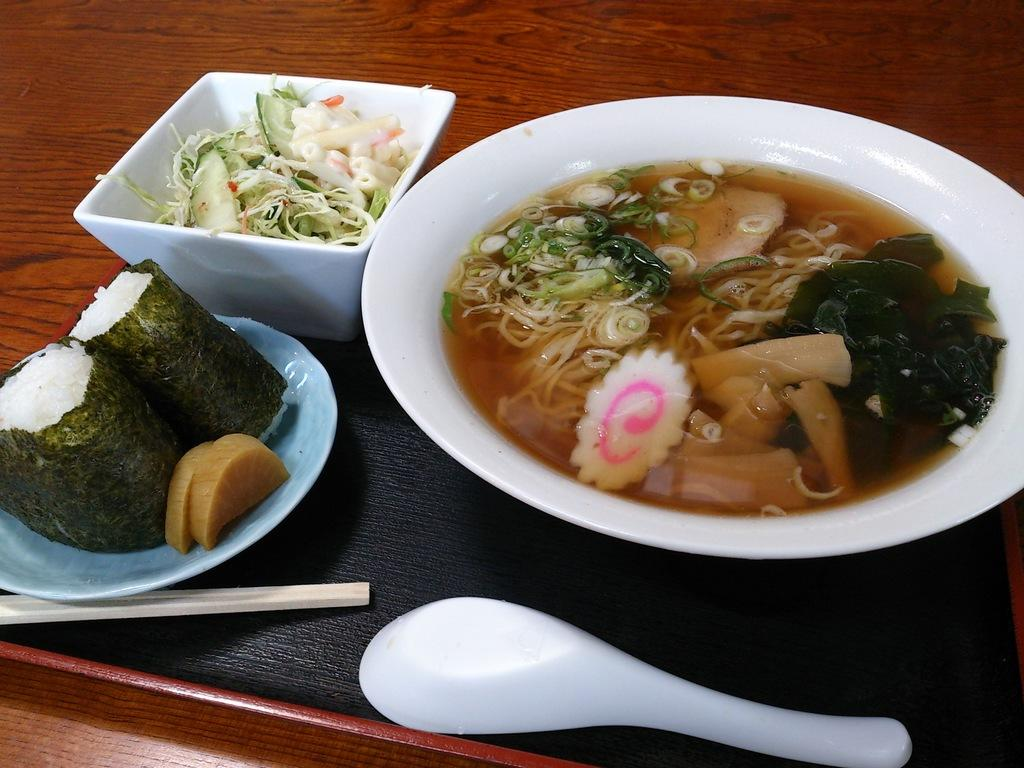What type of surface is the plates, tray, chopsticks, spoon, bowl, and food resting on? The plates, tray, chopsticks, spoon, bowl, and food are resting on a wooden table. What items can be found on the wooden table? There are plates, a tray, chopsticks, a spoon, a bowl, and food on the wooden table. What type of utensil is present on the wooden table? Chopsticks are present on the wooden table. What type of dishware is present on the wooden table? There is a bowl on the wooden table. What is visible on the wooden table? Food is visible on the wooden table. What color is the news on the wooden table? There is no news present on the wooden table in the image. How many circles can be seen on the wooden table? There are no circles visible on the wooden table in the image. 